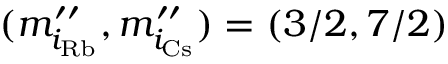Convert formula to latex. <formula><loc_0><loc_0><loc_500><loc_500>( m _ { i _ { R b } } ^ { \prime \prime } , m _ { i _ { C s } } ^ { \prime \prime } ) = ( 3 / 2 , 7 / 2 )</formula> 